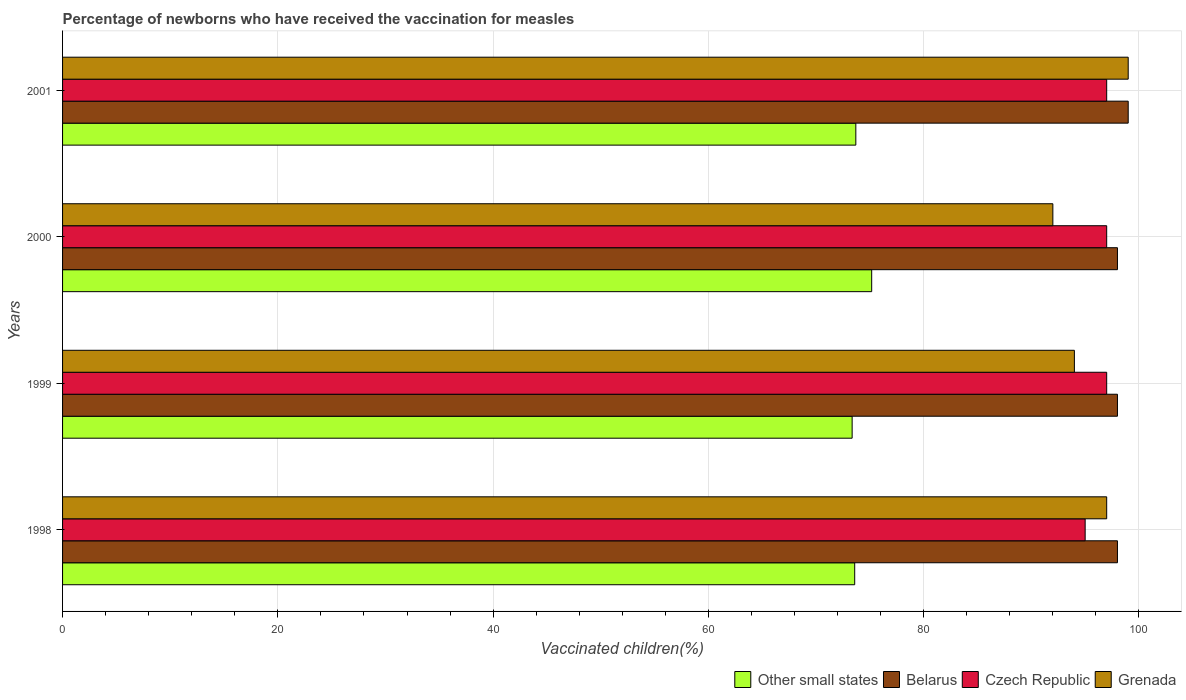Are the number of bars per tick equal to the number of legend labels?
Provide a succinct answer. Yes. Are the number of bars on each tick of the Y-axis equal?
Keep it short and to the point. Yes. How many bars are there on the 4th tick from the top?
Your answer should be very brief. 4. How many bars are there on the 3rd tick from the bottom?
Provide a succinct answer. 4. What is the label of the 2nd group of bars from the top?
Provide a succinct answer. 2000. In how many cases, is the number of bars for a given year not equal to the number of legend labels?
Keep it short and to the point. 0. Across all years, what is the maximum percentage of vaccinated children in Belarus?
Your answer should be very brief. 99. In which year was the percentage of vaccinated children in Czech Republic maximum?
Keep it short and to the point. 1999. In which year was the percentage of vaccinated children in Belarus minimum?
Your response must be concise. 1998. What is the total percentage of vaccinated children in Belarus in the graph?
Make the answer very short. 393. What is the difference between the percentage of vaccinated children in Czech Republic in 1998 and the percentage of vaccinated children in Grenada in 1999?
Keep it short and to the point. 1. What is the average percentage of vaccinated children in Grenada per year?
Offer a very short reply. 95.5. In the year 1998, what is the difference between the percentage of vaccinated children in Grenada and percentage of vaccinated children in Other small states?
Ensure brevity in your answer.  23.41. What is the ratio of the percentage of vaccinated children in Grenada in 1999 to that in 2000?
Offer a very short reply. 1.02. Is the percentage of vaccinated children in Czech Republic in 1998 less than that in 2000?
Your response must be concise. Yes. What is the difference between the highest and the lowest percentage of vaccinated children in Belarus?
Provide a short and direct response. 1. In how many years, is the percentage of vaccinated children in Other small states greater than the average percentage of vaccinated children in Other small states taken over all years?
Offer a terse response. 1. What does the 1st bar from the top in 2000 represents?
Provide a short and direct response. Grenada. What does the 3rd bar from the bottom in 1999 represents?
Ensure brevity in your answer.  Czech Republic. Is it the case that in every year, the sum of the percentage of vaccinated children in Grenada and percentage of vaccinated children in Belarus is greater than the percentage of vaccinated children in Czech Republic?
Your answer should be compact. Yes. How many years are there in the graph?
Keep it short and to the point. 4. Does the graph contain any zero values?
Your answer should be very brief. No. Does the graph contain grids?
Your answer should be very brief. Yes. How many legend labels are there?
Give a very brief answer. 4. How are the legend labels stacked?
Your answer should be compact. Horizontal. What is the title of the graph?
Provide a succinct answer. Percentage of newborns who have received the vaccination for measles. Does "Sri Lanka" appear as one of the legend labels in the graph?
Offer a very short reply. No. What is the label or title of the X-axis?
Make the answer very short. Vaccinated children(%). What is the Vaccinated children(%) of Other small states in 1998?
Your response must be concise. 73.59. What is the Vaccinated children(%) in Grenada in 1998?
Your answer should be compact. 97. What is the Vaccinated children(%) in Other small states in 1999?
Provide a short and direct response. 73.35. What is the Vaccinated children(%) of Czech Republic in 1999?
Provide a short and direct response. 97. What is the Vaccinated children(%) in Grenada in 1999?
Ensure brevity in your answer.  94. What is the Vaccinated children(%) of Other small states in 2000?
Provide a succinct answer. 75.17. What is the Vaccinated children(%) of Belarus in 2000?
Your response must be concise. 98. What is the Vaccinated children(%) of Czech Republic in 2000?
Offer a terse response. 97. What is the Vaccinated children(%) in Grenada in 2000?
Keep it short and to the point. 92. What is the Vaccinated children(%) in Other small states in 2001?
Make the answer very short. 73.7. What is the Vaccinated children(%) of Belarus in 2001?
Your response must be concise. 99. What is the Vaccinated children(%) in Czech Republic in 2001?
Your answer should be compact. 97. What is the Vaccinated children(%) in Grenada in 2001?
Ensure brevity in your answer.  99. Across all years, what is the maximum Vaccinated children(%) in Other small states?
Your response must be concise. 75.17. Across all years, what is the maximum Vaccinated children(%) of Czech Republic?
Your answer should be very brief. 97. Across all years, what is the minimum Vaccinated children(%) of Other small states?
Make the answer very short. 73.35. Across all years, what is the minimum Vaccinated children(%) in Grenada?
Make the answer very short. 92. What is the total Vaccinated children(%) of Other small states in the graph?
Offer a very short reply. 295.81. What is the total Vaccinated children(%) in Belarus in the graph?
Your answer should be very brief. 393. What is the total Vaccinated children(%) in Czech Republic in the graph?
Keep it short and to the point. 386. What is the total Vaccinated children(%) in Grenada in the graph?
Your answer should be very brief. 382. What is the difference between the Vaccinated children(%) in Other small states in 1998 and that in 1999?
Your answer should be very brief. 0.24. What is the difference between the Vaccinated children(%) in Belarus in 1998 and that in 1999?
Your answer should be compact. 0. What is the difference between the Vaccinated children(%) of Czech Republic in 1998 and that in 1999?
Offer a terse response. -2. What is the difference between the Vaccinated children(%) of Grenada in 1998 and that in 1999?
Keep it short and to the point. 3. What is the difference between the Vaccinated children(%) in Other small states in 1998 and that in 2000?
Your answer should be compact. -1.58. What is the difference between the Vaccinated children(%) of Other small states in 1998 and that in 2001?
Provide a succinct answer. -0.1. What is the difference between the Vaccinated children(%) of Czech Republic in 1998 and that in 2001?
Provide a short and direct response. -2. What is the difference between the Vaccinated children(%) of Grenada in 1998 and that in 2001?
Your answer should be compact. -2. What is the difference between the Vaccinated children(%) of Other small states in 1999 and that in 2000?
Make the answer very short. -1.82. What is the difference between the Vaccinated children(%) of Grenada in 1999 and that in 2000?
Make the answer very short. 2. What is the difference between the Vaccinated children(%) of Other small states in 1999 and that in 2001?
Your answer should be very brief. -0.34. What is the difference between the Vaccinated children(%) in Czech Republic in 1999 and that in 2001?
Your answer should be very brief. 0. What is the difference between the Vaccinated children(%) in Grenada in 1999 and that in 2001?
Offer a very short reply. -5. What is the difference between the Vaccinated children(%) in Other small states in 2000 and that in 2001?
Offer a very short reply. 1.47. What is the difference between the Vaccinated children(%) in Grenada in 2000 and that in 2001?
Ensure brevity in your answer.  -7. What is the difference between the Vaccinated children(%) in Other small states in 1998 and the Vaccinated children(%) in Belarus in 1999?
Ensure brevity in your answer.  -24.41. What is the difference between the Vaccinated children(%) in Other small states in 1998 and the Vaccinated children(%) in Czech Republic in 1999?
Your answer should be compact. -23.41. What is the difference between the Vaccinated children(%) in Other small states in 1998 and the Vaccinated children(%) in Grenada in 1999?
Keep it short and to the point. -20.41. What is the difference between the Vaccinated children(%) in Czech Republic in 1998 and the Vaccinated children(%) in Grenada in 1999?
Your response must be concise. 1. What is the difference between the Vaccinated children(%) of Other small states in 1998 and the Vaccinated children(%) of Belarus in 2000?
Give a very brief answer. -24.41. What is the difference between the Vaccinated children(%) of Other small states in 1998 and the Vaccinated children(%) of Czech Republic in 2000?
Offer a terse response. -23.41. What is the difference between the Vaccinated children(%) in Other small states in 1998 and the Vaccinated children(%) in Grenada in 2000?
Offer a very short reply. -18.41. What is the difference between the Vaccinated children(%) in Belarus in 1998 and the Vaccinated children(%) in Grenada in 2000?
Make the answer very short. 6. What is the difference between the Vaccinated children(%) in Other small states in 1998 and the Vaccinated children(%) in Belarus in 2001?
Offer a terse response. -25.41. What is the difference between the Vaccinated children(%) in Other small states in 1998 and the Vaccinated children(%) in Czech Republic in 2001?
Make the answer very short. -23.41. What is the difference between the Vaccinated children(%) of Other small states in 1998 and the Vaccinated children(%) of Grenada in 2001?
Ensure brevity in your answer.  -25.41. What is the difference between the Vaccinated children(%) of Belarus in 1998 and the Vaccinated children(%) of Czech Republic in 2001?
Ensure brevity in your answer.  1. What is the difference between the Vaccinated children(%) in Czech Republic in 1998 and the Vaccinated children(%) in Grenada in 2001?
Offer a very short reply. -4. What is the difference between the Vaccinated children(%) in Other small states in 1999 and the Vaccinated children(%) in Belarus in 2000?
Your answer should be compact. -24.65. What is the difference between the Vaccinated children(%) of Other small states in 1999 and the Vaccinated children(%) of Czech Republic in 2000?
Your response must be concise. -23.65. What is the difference between the Vaccinated children(%) in Other small states in 1999 and the Vaccinated children(%) in Grenada in 2000?
Your response must be concise. -18.65. What is the difference between the Vaccinated children(%) in Belarus in 1999 and the Vaccinated children(%) in Grenada in 2000?
Provide a succinct answer. 6. What is the difference between the Vaccinated children(%) of Other small states in 1999 and the Vaccinated children(%) of Belarus in 2001?
Provide a short and direct response. -25.65. What is the difference between the Vaccinated children(%) in Other small states in 1999 and the Vaccinated children(%) in Czech Republic in 2001?
Give a very brief answer. -23.65. What is the difference between the Vaccinated children(%) in Other small states in 1999 and the Vaccinated children(%) in Grenada in 2001?
Offer a terse response. -25.65. What is the difference between the Vaccinated children(%) of Belarus in 1999 and the Vaccinated children(%) of Grenada in 2001?
Provide a short and direct response. -1. What is the difference between the Vaccinated children(%) of Czech Republic in 1999 and the Vaccinated children(%) of Grenada in 2001?
Your response must be concise. -2. What is the difference between the Vaccinated children(%) in Other small states in 2000 and the Vaccinated children(%) in Belarus in 2001?
Your response must be concise. -23.83. What is the difference between the Vaccinated children(%) in Other small states in 2000 and the Vaccinated children(%) in Czech Republic in 2001?
Offer a very short reply. -21.83. What is the difference between the Vaccinated children(%) in Other small states in 2000 and the Vaccinated children(%) in Grenada in 2001?
Offer a terse response. -23.83. What is the difference between the Vaccinated children(%) in Belarus in 2000 and the Vaccinated children(%) in Czech Republic in 2001?
Make the answer very short. 1. What is the difference between the Vaccinated children(%) of Belarus in 2000 and the Vaccinated children(%) of Grenada in 2001?
Offer a terse response. -1. What is the difference between the Vaccinated children(%) of Czech Republic in 2000 and the Vaccinated children(%) of Grenada in 2001?
Your answer should be compact. -2. What is the average Vaccinated children(%) of Other small states per year?
Make the answer very short. 73.95. What is the average Vaccinated children(%) of Belarus per year?
Keep it short and to the point. 98.25. What is the average Vaccinated children(%) in Czech Republic per year?
Your response must be concise. 96.5. What is the average Vaccinated children(%) of Grenada per year?
Your answer should be very brief. 95.5. In the year 1998, what is the difference between the Vaccinated children(%) of Other small states and Vaccinated children(%) of Belarus?
Provide a short and direct response. -24.41. In the year 1998, what is the difference between the Vaccinated children(%) in Other small states and Vaccinated children(%) in Czech Republic?
Give a very brief answer. -21.41. In the year 1998, what is the difference between the Vaccinated children(%) in Other small states and Vaccinated children(%) in Grenada?
Give a very brief answer. -23.41. In the year 1998, what is the difference between the Vaccinated children(%) of Belarus and Vaccinated children(%) of Czech Republic?
Provide a succinct answer. 3. In the year 1998, what is the difference between the Vaccinated children(%) of Belarus and Vaccinated children(%) of Grenada?
Your answer should be very brief. 1. In the year 1998, what is the difference between the Vaccinated children(%) of Czech Republic and Vaccinated children(%) of Grenada?
Offer a very short reply. -2. In the year 1999, what is the difference between the Vaccinated children(%) in Other small states and Vaccinated children(%) in Belarus?
Your answer should be very brief. -24.65. In the year 1999, what is the difference between the Vaccinated children(%) in Other small states and Vaccinated children(%) in Czech Republic?
Provide a succinct answer. -23.65. In the year 1999, what is the difference between the Vaccinated children(%) in Other small states and Vaccinated children(%) in Grenada?
Offer a terse response. -20.65. In the year 1999, what is the difference between the Vaccinated children(%) in Belarus and Vaccinated children(%) in Czech Republic?
Make the answer very short. 1. In the year 1999, what is the difference between the Vaccinated children(%) in Belarus and Vaccinated children(%) in Grenada?
Make the answer very short. 4. In the year 1999, what is the difference between the Vaccinated children(%) of Czech Republic and Vaccinated children(%) of Grenada?
Provide a succinct answer. 3. In the year 2000, what is the difference between the Vaccinated children(%) of Other small states and Vaccinated children(%) of Belarus?
Your response must be concise. -22.83. In the year 2000, what is the difference between the Vaccinated children(%) of Other small states and Vaccinated children(%) of Czech Republic?
Offer a terse response. -21.83. In the year 2000, what is the difference between the Vaccinated children(%) of Other small states and Vaccinated children(%) of Grenada?
Your answer should be compact. -16.83. In the year 2000, what is the difference between the Vaccinated children(%) of Belarus and Vaccinated children(%) of Czech Republic?
Offer a terse response. 1. In the year 2000, what is the difference between the Vaccinated children(%) in Czech Republic and Vaccinated children(%) in Grenada?
Your response must be concise. 5. In the year 2001, what is the difference between the Vaccinated children(%) of Other small states and Vaccinated children(%) of Belarus?
Your answer should be compact. -25.3. In the year 2001, what is the difference between the Vaccinated children(%) of Other small states and Vaccinated children(%) of Czech Republic?
Your response must be concise. -23.3. In the year 2001, what is the difference between the Vaccinated children(%) in Other small states and Vaccinated children(%) in Grenada?
Your answer should be very brief. -25.3. In the year 2001, what is the difference between the Vaccinated children(%) of Belarus and Vaccinated children(%) of Czech Republic?
Your response must be concise. 2. What is the ratio of the Vaccinated children(%) of Other small states in 1998 to that in 1999?
Provide a succinct answer. 1. What is the ratio of the Vaccinated children(%) of Belarus in 1998 to that in 1999?
Offer a terse response. 1. What is the ratio of the Vaccinated children(%) in Czech Republic in 1998 to that in 1999?
Your answer should be compact. 0.98. What is the ratio of the Vaccinated children(%) of Grenada in 1998 to that in 1999?
Offer a very short reply. 1.03. What is the ratio of the Vaccinated children(%) in Czech Republic in 1998 to that in 2000?
Give a very brief answer. 0.98. What is the ratio of the Vaccinated children(%) of Grenada in 1998 to that in 2000?
Offer a terse response. 1.05. What is the ratio of the Vaccinated children(%) in Belarus in 1998 to that in 2001?
Give a very brief answer. 0.99. What is the ratio of the Vaccinated children(%) in Czech Republic in 1998 to that in 2001?
Make the answer very short. 0.98. What is the ratio of the Vaccinated children(%) of Grenada in 1998 to that in 2001?
Your answer should be compact. 0.98. What is the ratio of the Vaccinated children(%) of Other small states in 1999 to that in 2000?
Offer a terse response. 0.98. What is the ratio of the Vaccinated children(%) of Czech Republic in 1999 to that in 2000?
Your answer should be very brief. 1. What is the ratio of the Vaccinated children(%) in Grenada in 1999 to that in 2000?
Provide a succinct answer. 1.02. What is the ratio of the Vaccinated children(%) in Belarus in 1999 to that in 2001?
Offer a very short reply. 0.99. What is the ratio of the Vaccinated children(%) in Czech Republic in 1999 to that in 2001?
Your response must be concise. 1. What is the ratio of the Vaccinated children(%) in Grenada in 1999 to that in 2001?
Make the answer very short. 0.95. What is the ratio of the Vaccinated children(%) of Belarus in 2000 to that in 2001?
Provide a short and direct response. 0.99. What is the ratio of the Vaccinated children(%) in Grenada in 2000 to that in 2001?
Give a very brief answer. 0.93. What is the difference between the highest and the second highest Vaccinated children(%) of Other small states?
Keep it short and to the point. 1.47. What is the difference between the highest and the second highest Vaccinated children(%) of Czech Republic?
Offer a very short reply. 0. What is the difference between the highest and the second highest Vaccinated children(%) of Grenada?
Your answer should be compact. 2. What is the difference between the highest and the lowest Vaccinated children(%) of Other small states?
Keep it short and to the point. 1.82. What is the difference between the highest and the lowest Vaccinated children(%) of Czech Republic?
Provide a short and direct response. 2. What is the difference between the highest and the lowest Vaccinated children(%) in Grenada?
Your answer should be compact. 7. 